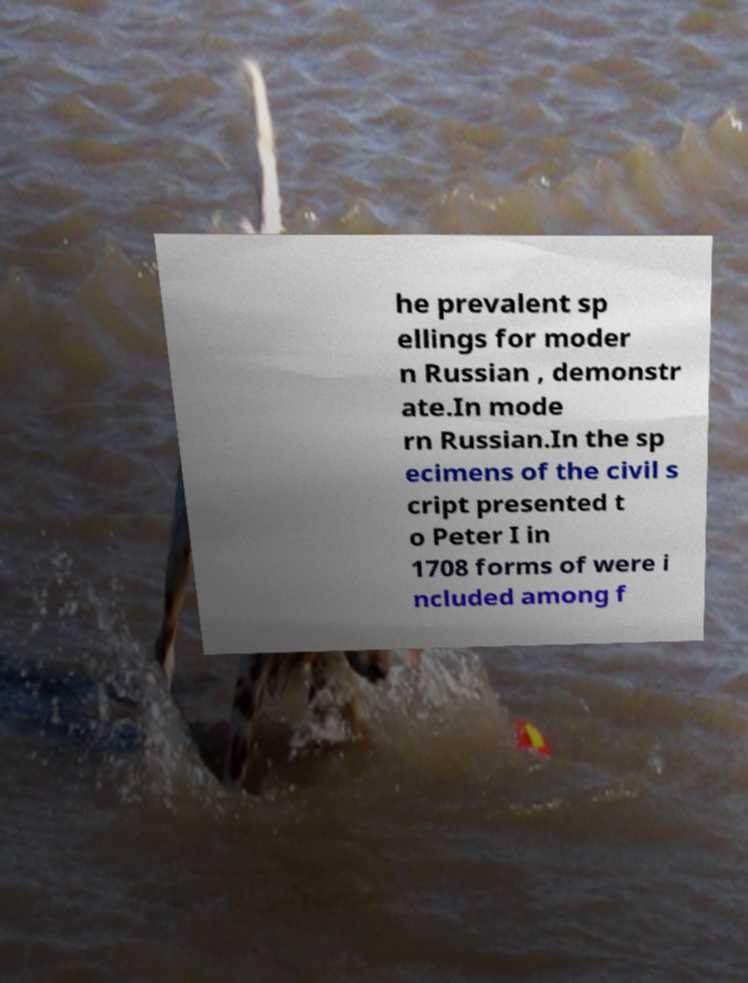What messages or text are displayed in this image? I need them in a readable, typed format. he prevalent sp ellings for moder n Russian , demonstr ate.In mode rn Russian.In the sp ecimens of the civil s cript presented t o Peter I in 1708 forms of were i ncluded among f 